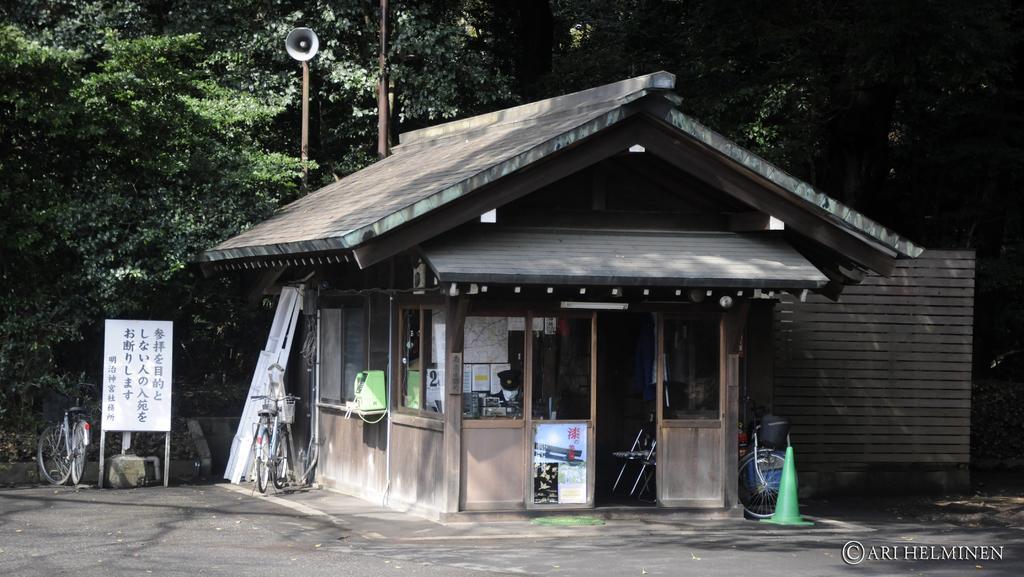Describe this image in one or two sentences. This picture is taken from the outside of the city. In this image, in the middle, we can see a house, in the house, we can see two chairs and a glass door. On the glass door, we can see some posts are attached to it. On the left side of the house, we can see electronic gadgets. On the right side, we can see a bicycle and a object which is placed on the road. On the left side, we can see a bicycle, a board with some text written on it. In the background, we can see a microphone, pole, trees, plants. At the bottom, we can see a road. 